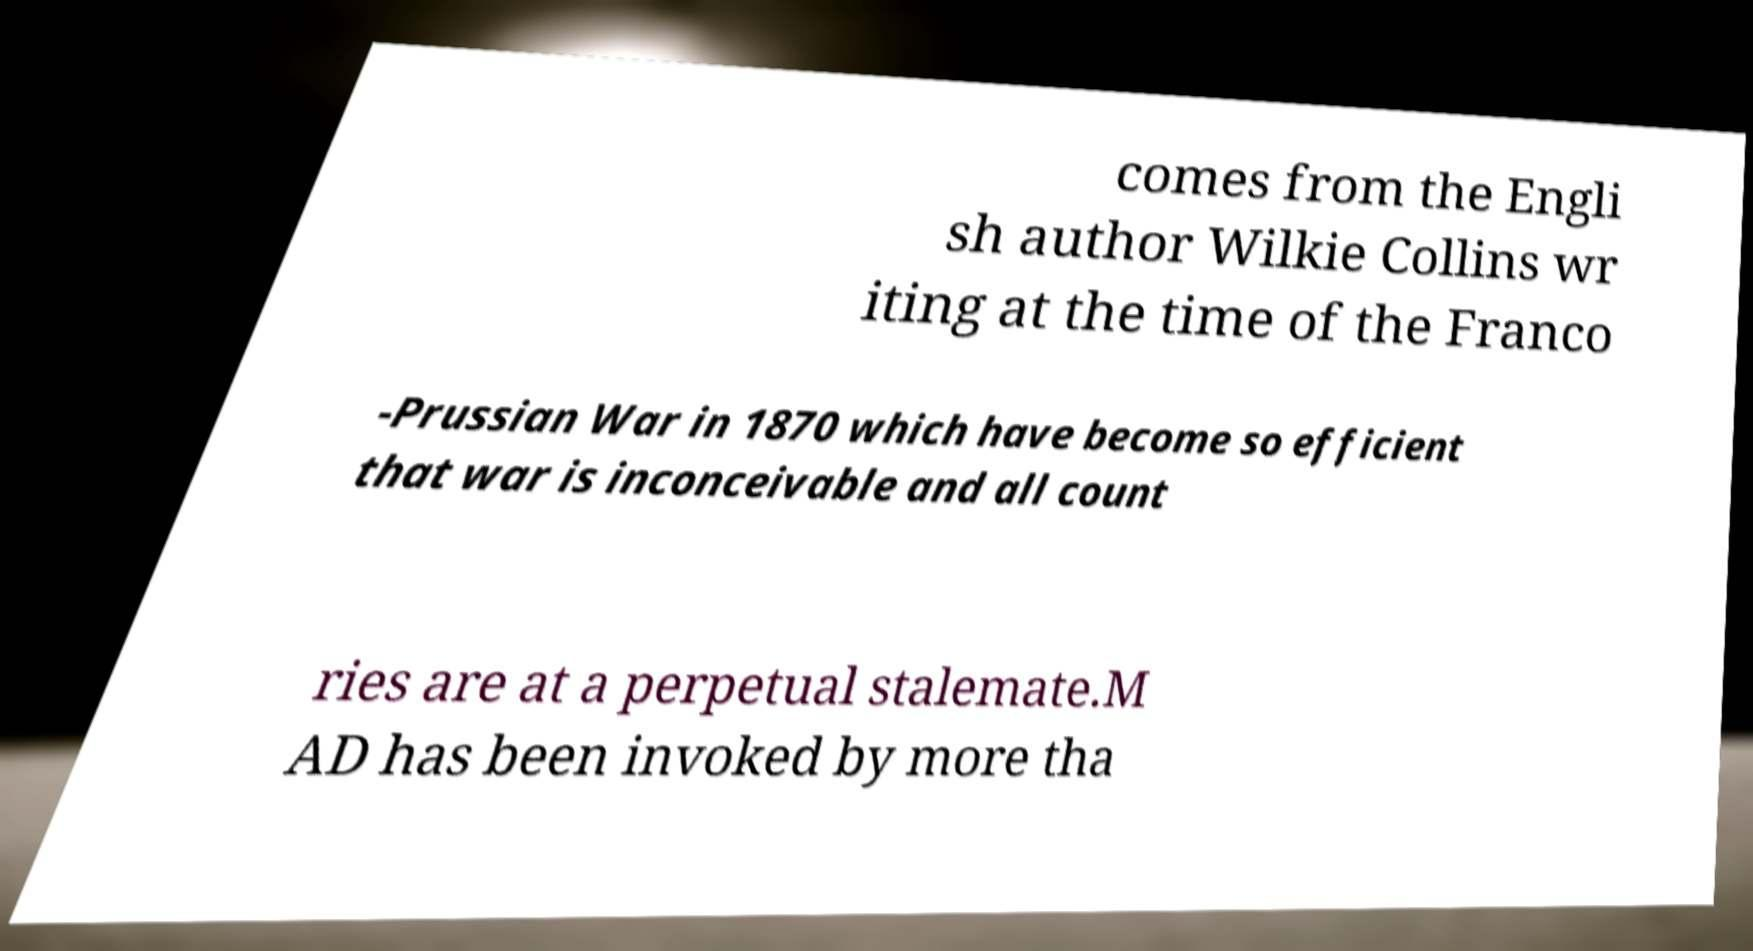Please identify and transcribe the text found in this image. comes from the Engli sh author Wilkie Collins wr iting at the time of the Franco -Prussian War in 1870 which have become so efficient that war is inconceivable and all count ries are at a perpetual stalemate.M AD has been invoked by more tha 